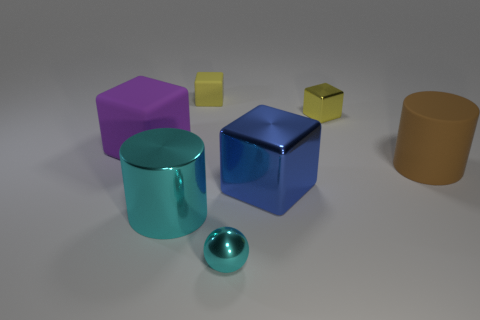Is there a pattern to the arrangement of these objects? There doesn't seem to be a deliberate pattern to the arrangement; the objects are scattered randomly with varying distances between them. 